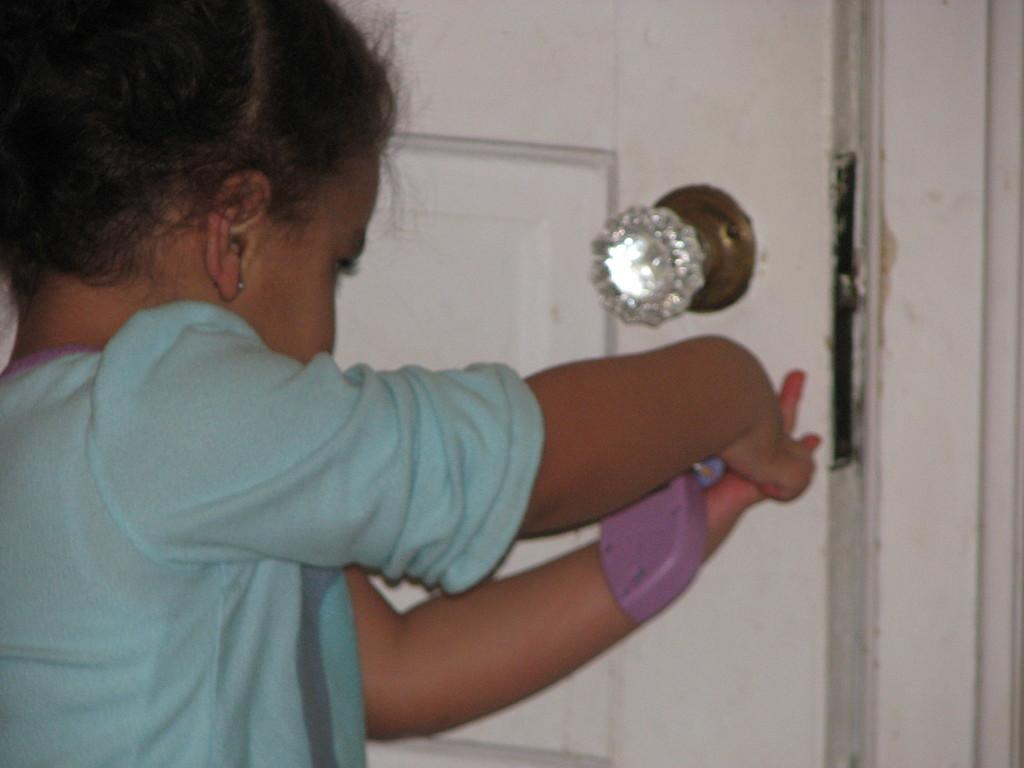Who is the main subject in the image? There is a small girl in the image. What is the girl wearing? The girl is wearing a t-shirt. What is the girl holding in her hand? The girl is holding something in her hand, but the image does not specify what it is. What is the girl trying to do in the image? The girl is trying to open a door. What feature of the door is visible in the image? There is a handle attached to the door. What type of popcorn is being served during the show in the image? There is no show or popcorn present in the image; it features a small girl trying to open a door. How much dust can be seen on the floor in the image? There is no mention of dust or a floor in the image; it focuses on the girl and the door. 